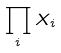<formula> <loc_0><loc_0><loc_500><loc_500>\prod _ { i } X _ { i }</formula> 